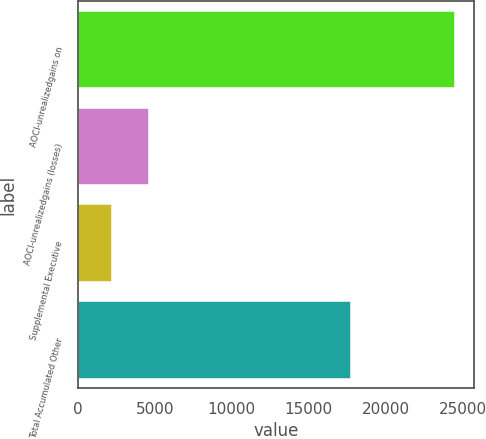Convert chart. <chart><loc_0><loc_0><loc_500><loc_500><bar_chart><fcel>AOCI-unrealizedgains on<fcel>AOCI-unrealizedgains (losses)<fcel>Supplemental Executive<fcel>Total Accumulated Other<nl><fcel>24536<fcel>4596<fcel>2215<fcel>17725<nl></chart> 